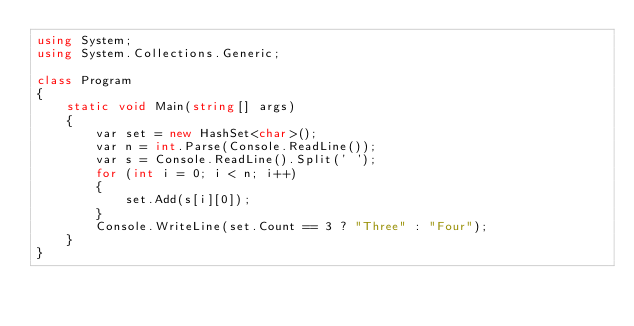<code> <loc_0><loc_0><loc_500><loc_500><_C#_>using System;
using System.Collections.Generic;

class Program
{
    static void Main(string[] args)
    {
        var set = new HashSet<char>();
        var n = int.Parse(Console.ReadLine());
        var s = Console.ReadLine().Split(' ');
        for (int i = 0; i < n; i++)
        {
            set.Add(s[i][0]);
        }
        Console.WriteLine(set.Count == 3 ? "Three" : "Four");
    }
}
</code> 